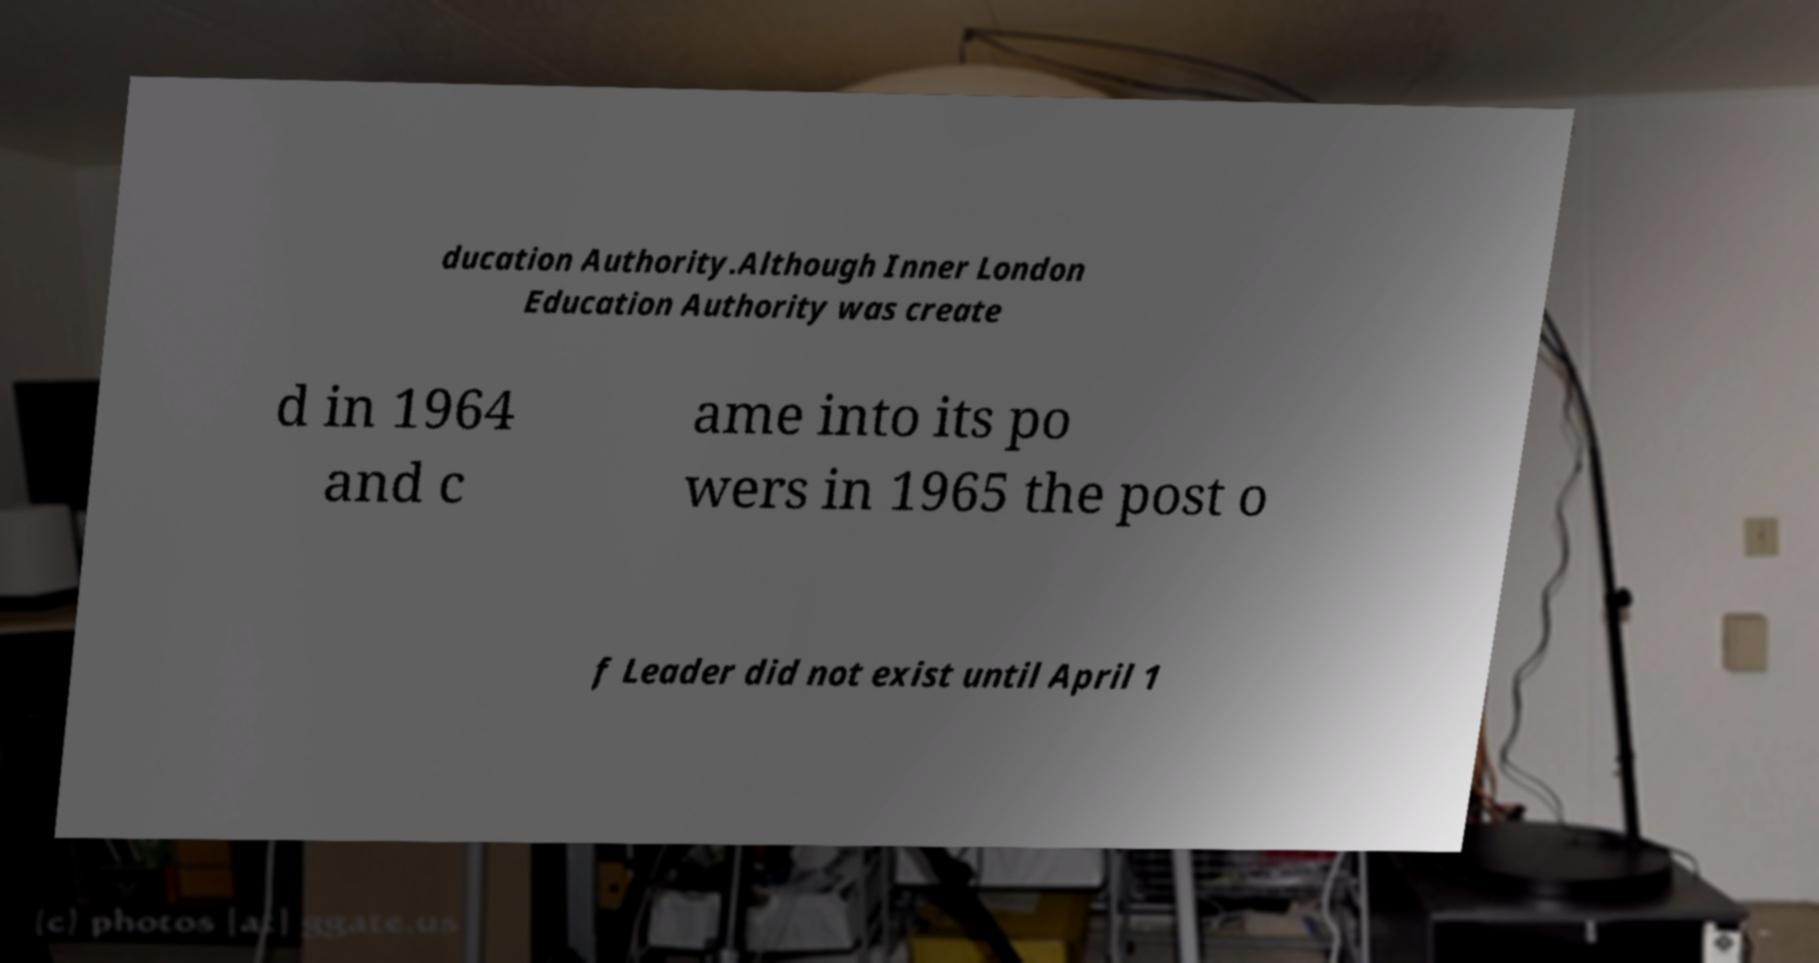For documentation purposes, I need the text within this image transcribed. Could you provide that? ducation Authority.Although Inner London Education Authority was create d in 1964 and c ame into its po wers in 1965 the post o f Leader did not exist until April 1 